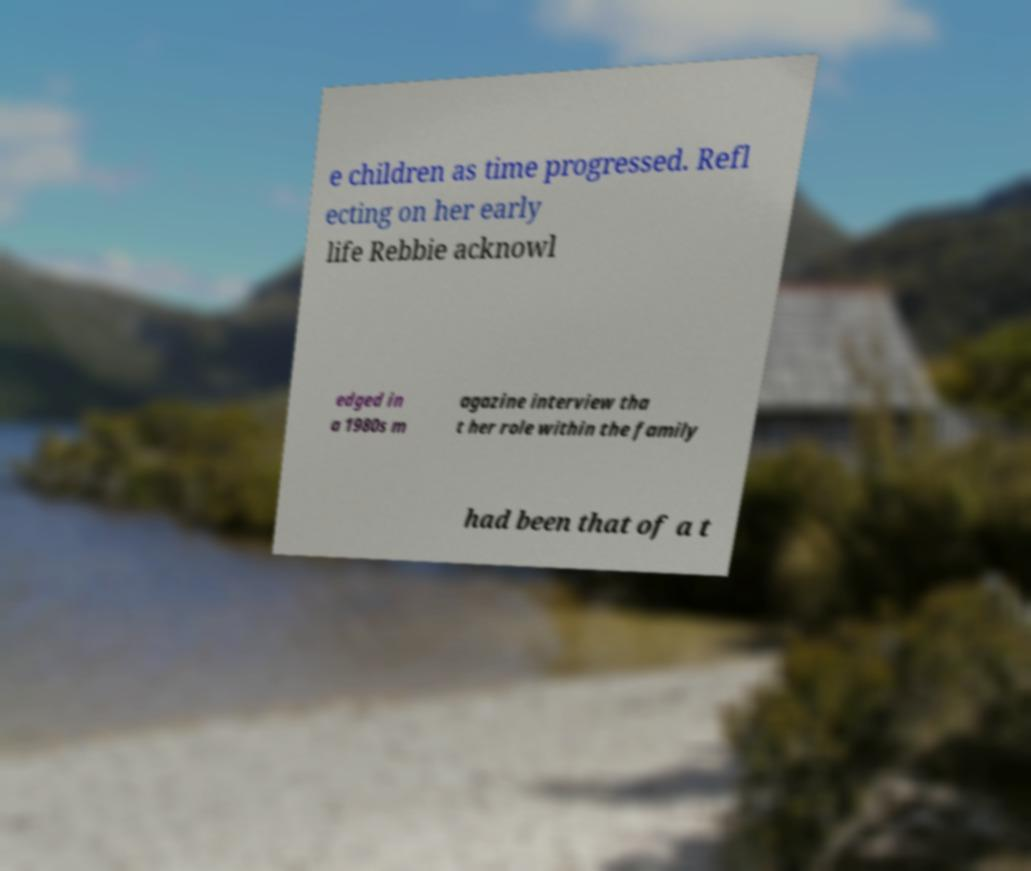I need the written content from this picture converted into text. Can you do that? e children as time progressed. Refl ecting on her early life Rebbie acknowl edged in a 1980s m agazine interview tha t her role within the family had been that of a t 